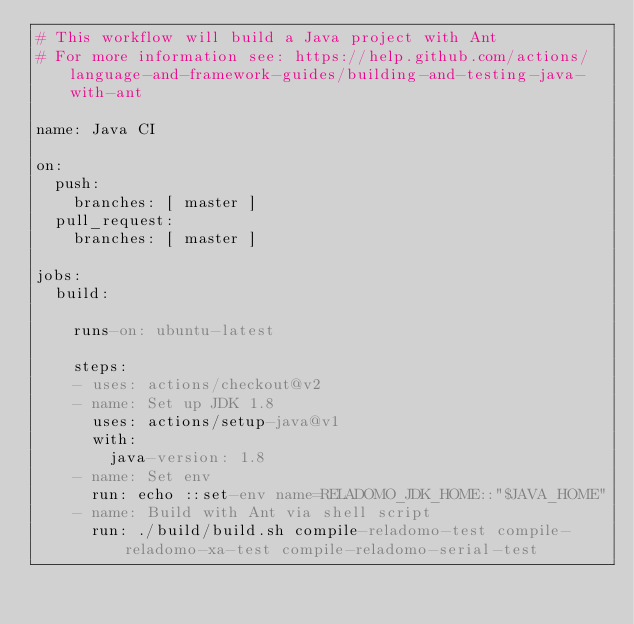<code> <loc_0><loc_0><loc_500><loc_500><_YAML_># This workflow will build a Java project with Ant
# For more information see: https://help.github.com/actions/language-and-framework-guides/building-and-testing-java-with-ant

name: Java CI

on:
  push:
    branches: [ master ]
  pull_request:
    branches: [ master ]

jobs:
  build:

    runs-on: ubuntu-latest

    steps:
    - uses: actions/checkout@v2
    - name: Set up JDK 1.8
      uses: actions/setup-java@v1
      with:
        java-version: 1.8
    - name: Set env
      run: echo ::set-env name=RELADOMO_JDK_HOME::"$JAVA_HOME"
    - name: Build with Ant via shell script
      run: ./build/build.sh compile-reladomo-test compile-reladomo-xa-test compile-reladomo-serial-test
</code> 